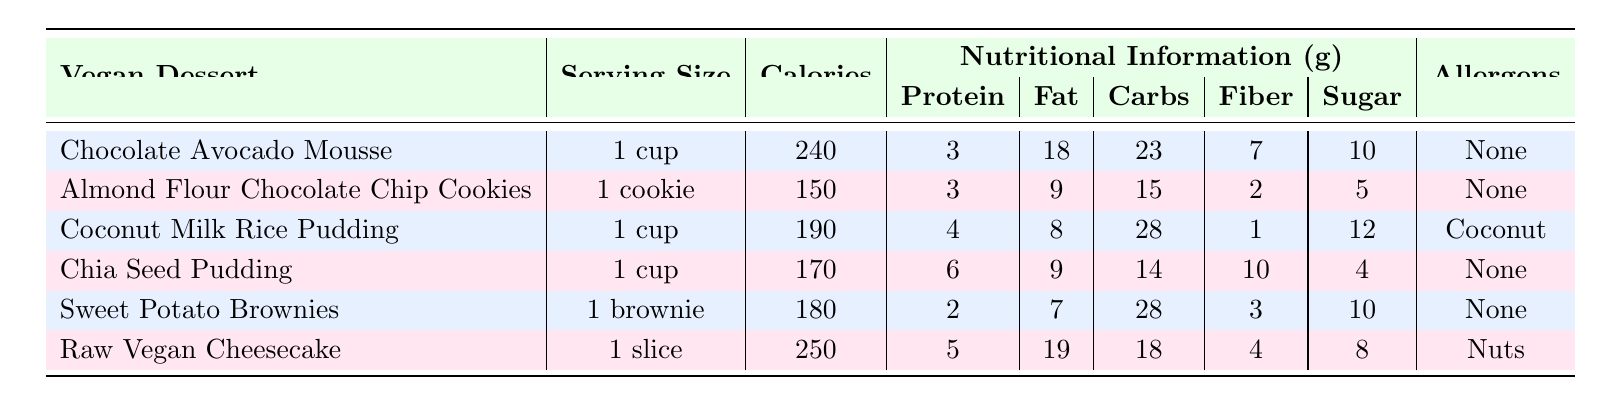What is the serving size of Chocolate Avocado Mousse? The serving size for Chocolate Avocado Mousse is listed in the table, which states "1 cup."
Answer: 1 cup How many calories are in Almond Flour Chocolate Chip Cookies? The table indicates that Almond Flour Chocolate Chip Cookies contain 150 calories per cookie.
Answer: 150 Which dessert has the highest sugar content? Comparing the sugar content of all desserts, Chocolate Avocado Mousse has 10g, Almond Flour Chocolate Chip Cookies has 5g, Coconut Milk Rice Pudding has 12g, Chia Seed Pudding has 4g, Sweet Potato Brownies has 10g, and Raw Vegan Cheesecake has 8g. Coconut Milk Rice Pudding has the highest at 12g.
Answer: Coconut Milk Rice Pudding What is the total fat content in Chia Seed Pudding and Almond Flour Chocolate Chip Cookies combined? Chia Seed Pudding contains 9g of fat, and Almond Flour Chocolate Chip Cookies contain 9g of fat. Therefore, the combined total fat content is 9 + 9 = 18g.
Answer: 18g Are all the desserts free from allergens? The table lists the allergens for each dessert. Chocolate Avocado Mousse, Almond Flour Chocolate Chip Cookies, Chia Seed Pudding, and Sweet Potato Brownies have "None" listed as allergens. However, Coconut Milk Rice Pudding contains coconut, and Raw Vegan Cheesecake contains nuts, indicating that not all desserts are allergen-free.
Answer: No What is the average calorie content of the desserts listed? To find the average calorie content, sum the calories: 240 + 150 + 190 + 170 + 180 + 250 = 1,180 calories. There are 6 desserts, so the average is 1,180 / 6 = 196.67, which can be rounded to 197.
Answer: 197 Which dessert offers the most protein per serving? The protein amounts per serving are: Chocolate Avocado Mousse = 3g, Almond Flour Chocolate Chip Cookies = 3g, Coconut Milk Rice Pudding = 4g, Chia Seed Pudding = 6g, Sweet Potato Brownies = 2g, and Raw Vegan Cheesecake = 5g. Chia Seed Pudding has the highest at 6g.
Answer: Chia Seed Pudding How much fiber does Raw Vegan Cheesecake contain? The table states that Raw Vegan Cheesecake contains 4g of fiber.
Answer: 4g Which dessert has the highest calorie count and what is it? By evaluating the calorie counts: 240 for Chocolate Avocado Mousse, 150 for Almond Flour Chocolate Chip Cookies, 190 for Coconut Milk Rice Pudding, 170 for Chia Seed Pudding, 180 for Sweet Potato Brownies, and 250 for Raw Vegan Cheesecake, the highest calorie count is 250 from Raw Vegan Cheesecake.
Answer: Raw Vegan Cheesecake, 250 calories 